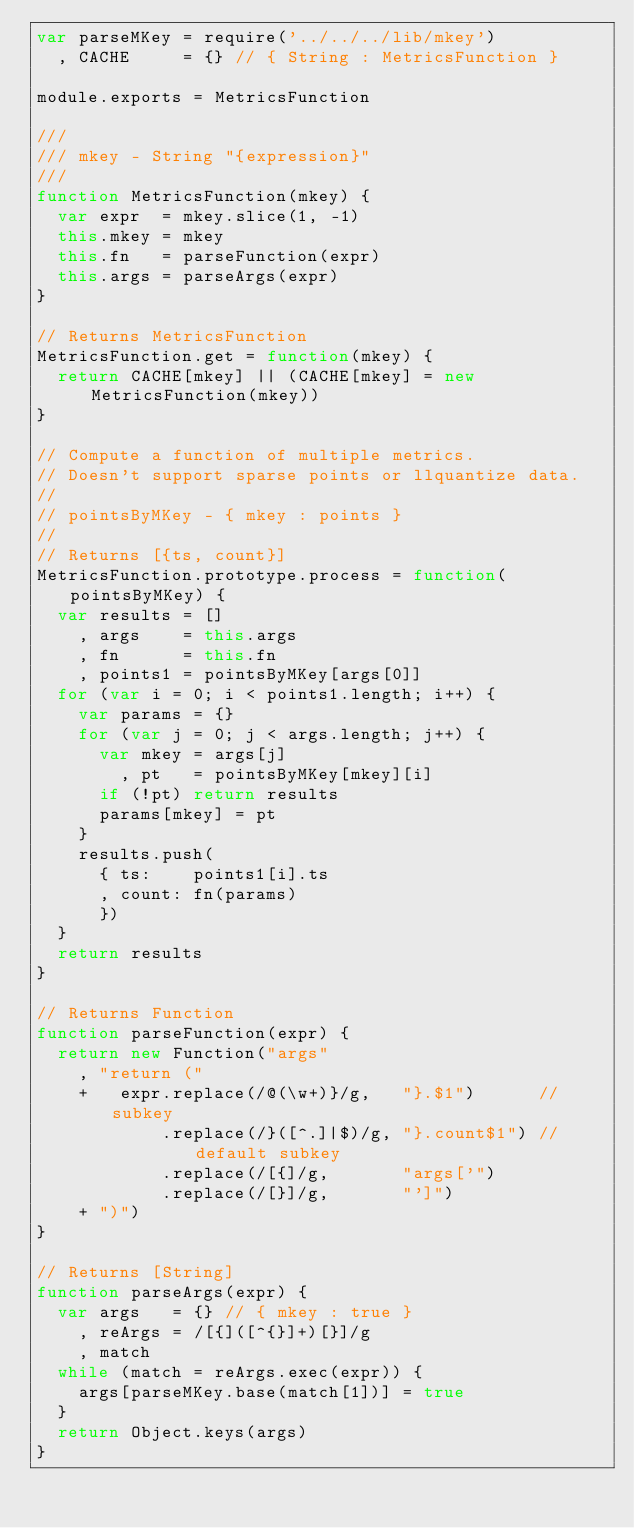<code> <loc_0><loc_0><loc_500><loc_500><_JavaScript_>var parseMKey = require('../../../lib/mkey')
  , CACHE     = {} // { String : MetricsFunction }

module.exports = MetricsFunction

///
/// mkey - String "{expression}"
///
function MetricsFunction(mkey) {
  var expr  = mkey.slice(1, -1)
  this.mkey = mkey
  this.fn   = parseFunction(expr)
  this.args = parseArgs(expr)
}

// Returns MetricsFunction
MetricsFunction.get = function(mkey) {
  return CACHE[mkey] || (CACHE[mkey] = new MetricsFunction(mkey))
}

// Compute a function of multiple metrics.
// Doesn't support sparse points or llquantize data.
//
// pointsByMKey - { mkey : points }
//
// Returns [{ts, count}]
MetricsFunction.prototype.process = function(pointsByMKey) {
  var results = []
    , args    = this.args
    , fn      = this.fn
    , points1 = pointsByMKey[args[0]]
  for (var i = 0; i < points1.length; i++) {
    var params = {}
    for (var j = 0; j < args.length; j++) {
      var mkey = args[j]
        , pt   = pointsByMKey[mkey][i]
      if (!pt) return results
      params[mkey] = pt
    }
    results.push(
      { ts:    points1[i].ts
      , count: fn(params)
      })
  }
  return results
}

// Returns Function
function parseFunction(expr) {
  return new Function("args"
    , "return ("
    +   expr.replace(/@(\w+)}/g,   "}.$1")      // subkey
            .replace(/}([^.]|$)/g, "}.count$1") // default subkey
            .replace(/[{]/g,       "args['")
            .replace(/[}]/g,       "']")
    + ")")
}

// Returns [String]
function parseArgs(expr) {
  var args   = {} // { mkey : true }
    , reArgs = /[{]([^{}]+)[}]/g
    , match
  while (match = reArgs.exec(expr)) {
    args[parseMKey.base(match[1])] = true
  }
  return Object.keys(args)
}
</code> 